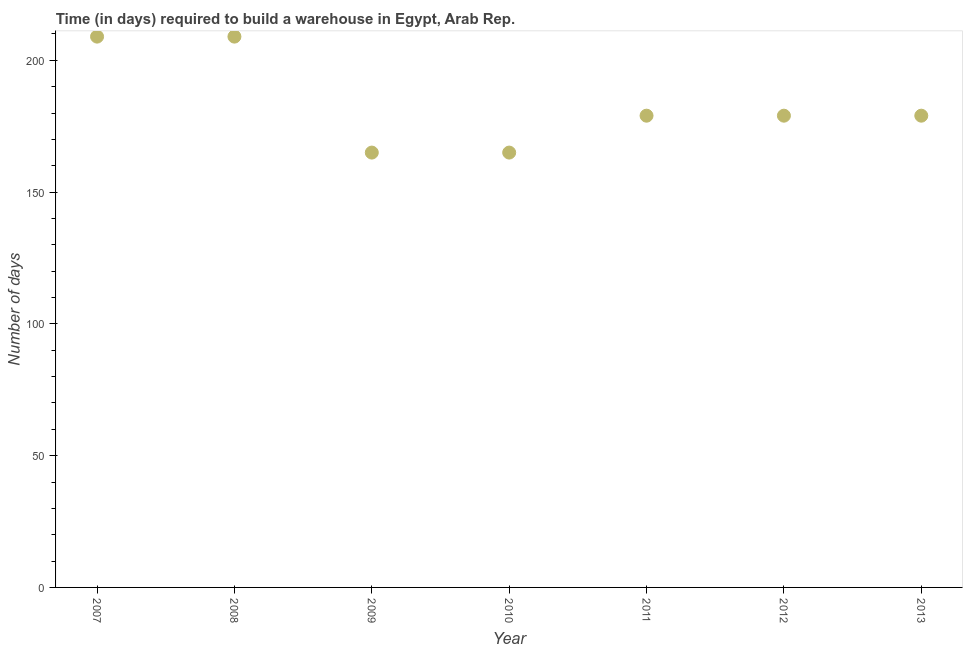What is the time required to build a warehouse in 2013?
Your answer should be very brief. 179. Across all years, what is the maximum time required to build a warehouse?
Give a very brief answer. 209. Across all years, what is the minimum time required to build a warehouse?
Your answer should be compact. 165. In which year was the time required to build a warehouse minimum?
Give a very brief answer. 2009. What is the sum of the time required to build a warehouse?
Provide a succinct answer. 1285. What is the difference between the time required to build a warehouse in 2007 and 2013?
Offer a terse response. 30. What is the average time required to build a warehouse per year?
Give a very brief answer. 183.57. What is the median time required to build a warehouse?
Your answer should be very brief. 179. In how many years, is the time required to build a warehouse greater than 70 days?
Give a very brief answer. 7. What is the ratio of the time required to build a warehouse in 2007 to that in 2009?
Ensure brevity in your answer.  1.27. Is the sum of the time required to build a warehouse in 2007 and 2013 greater than the maximum time required to build a warehouse across all years?
Your answer should be very brief. Yes. What is the difference between the highest and the lowest time required to build a warehouse?
Keep it short and to the point. 44. In how many years, is the time required to build a warehouse greater than the average time required to build a warehouse taken over all years?
Give a very brief answer. 2. Does the time required to build a warehouse monotonically increase over the years?
Make the answer very short. No. How many years are there in the graph?
Make the answer very short. 7. Does the graph contain grids?
Ensure brevity in your answer.  No. What is the title of the graph?
Ensure brevity in your answer.  Time (in days) required to build a warehouse in Egypt, Arab Rep. What is the label or title of the Y-axis?
Provide a succinct answer. Number of days. What is the Number of days in 2007?
Your answer should be very brief. 209. What is the Number of days in 2008?
Give a very brief answer. 209. What is the Number of days in 2009?
Ensure brevity in your answer.  165. What is the Number of days in 2010?
Make the answer very short. 165. What is the Number of days in 2011?
Offer a terse response. 179. What is the Number of days in 2012?
Provide a short and direct response. 179. What is the Number of days in 2013?
Give a very brief answer. 179. What is the difference between the Number of days in 2007 and 2008?
Provide a succinct answer. 0. What is the difference between the Number of days in 2007 and 2011?
Make the answer very short. 30. What is the difference between the Number of days in 2007 and 2012?
Keep it short and to the point. 30. What is the difference between the Number of days in 2008 and 2012?
Make the answer very short. 30. What is the difference between the Number of days in 2009 and 2010?
Ensure brevity in your answer.  0. What is the difference between the Number of days in 2009 and 2011?
Your response must be concise. -14. What is the difference between the Number of days in 2009 and 2012?
Keep it short and to the point. -14. What is the difference between the Number of days in 2009 and 2013?
Offer a very short reply. -14. What is the difference between the Number of days in 2010 and 2011?
Make the answer very short. -14. What is the difference between the Number of days in 2010 and 2013?
Make the answer very short. -14. What is the difference between the Number of days in 2011 and 2012?
Ensure brevity in your answer.  0. What is the difference between the Number of days in 2011 and 2013?
Offer a very short reply. 0. What is the ratio of the Number of days in 2007 to that in 2008?
Ensure brevity in your answer.  1. What is the ratio of the Number of days in 2007 to that in 2009?
Your answer should be very brief. 1.27. What is the ratio of the Number of days in 2007 to that in 2010?
Your answer should be compact. 1.27. What is the ratio of the Number of days in 2007 to that in 2011?
Offer a terse response. 1.17. What is the ratio of the Number of days in 2007 to that in 2012?
Offer a very short reply. 1.17. What is the ratio of the Number of days in 2007 to that in 2013?
Your response must be concise. 1.17. What is the ratio of the Number of days in 2008 to that in 2009?
Provide a succinct answer. 1.27. What is the ratio of the Number of days in 2008 to that in 2010?
Keep it short and to the point. 1.27. What is the ratio of the Number of days in 2008 to that in 2011?
Offer a terse response. 1.17. What is the ratio of the Number of days in 2008 to that in 2012?
Provide a short and direct response. 1.17. What is the ratio of the Number of days in 2008 to that in 2013?
Offer a terse response. 1.17. What is the ratio of the Number of days in 2009 to that in 2010?
Ensure brevity in your answer.  1. What is the ratio of the Number of days in 2009 to that in 2011?
Make the answer very short. 0.92. What is the ratio of the Number of days in 2009 to that in 2012?
Offer a very short reply. 0.92. What is the ratio of the Number of days in 2009 to that in 2013?
Offer a very short reply. 0.92. What is the ratio of the Number of days in 2010 to that in 2011?
Your response must be concise. 0.92. What is the ratio of the Number of days in 2010 to that in 2012?
Ensure brevity in your answer.  0.92. What is the ratio of the Number of days in 2010 to that in 2013?
Your answer should be very brief. 0.92. What is the ratio of the Number of days in 2011 to that in 2012?
Offer a terse response. 1. What is the ratio of the Number of days in 2011 to that in 2013?
Provide a succinct answer. 1. What is the ratio of the Number of days in 2012 to that in 2013?
Give a very brief answer. 1. 